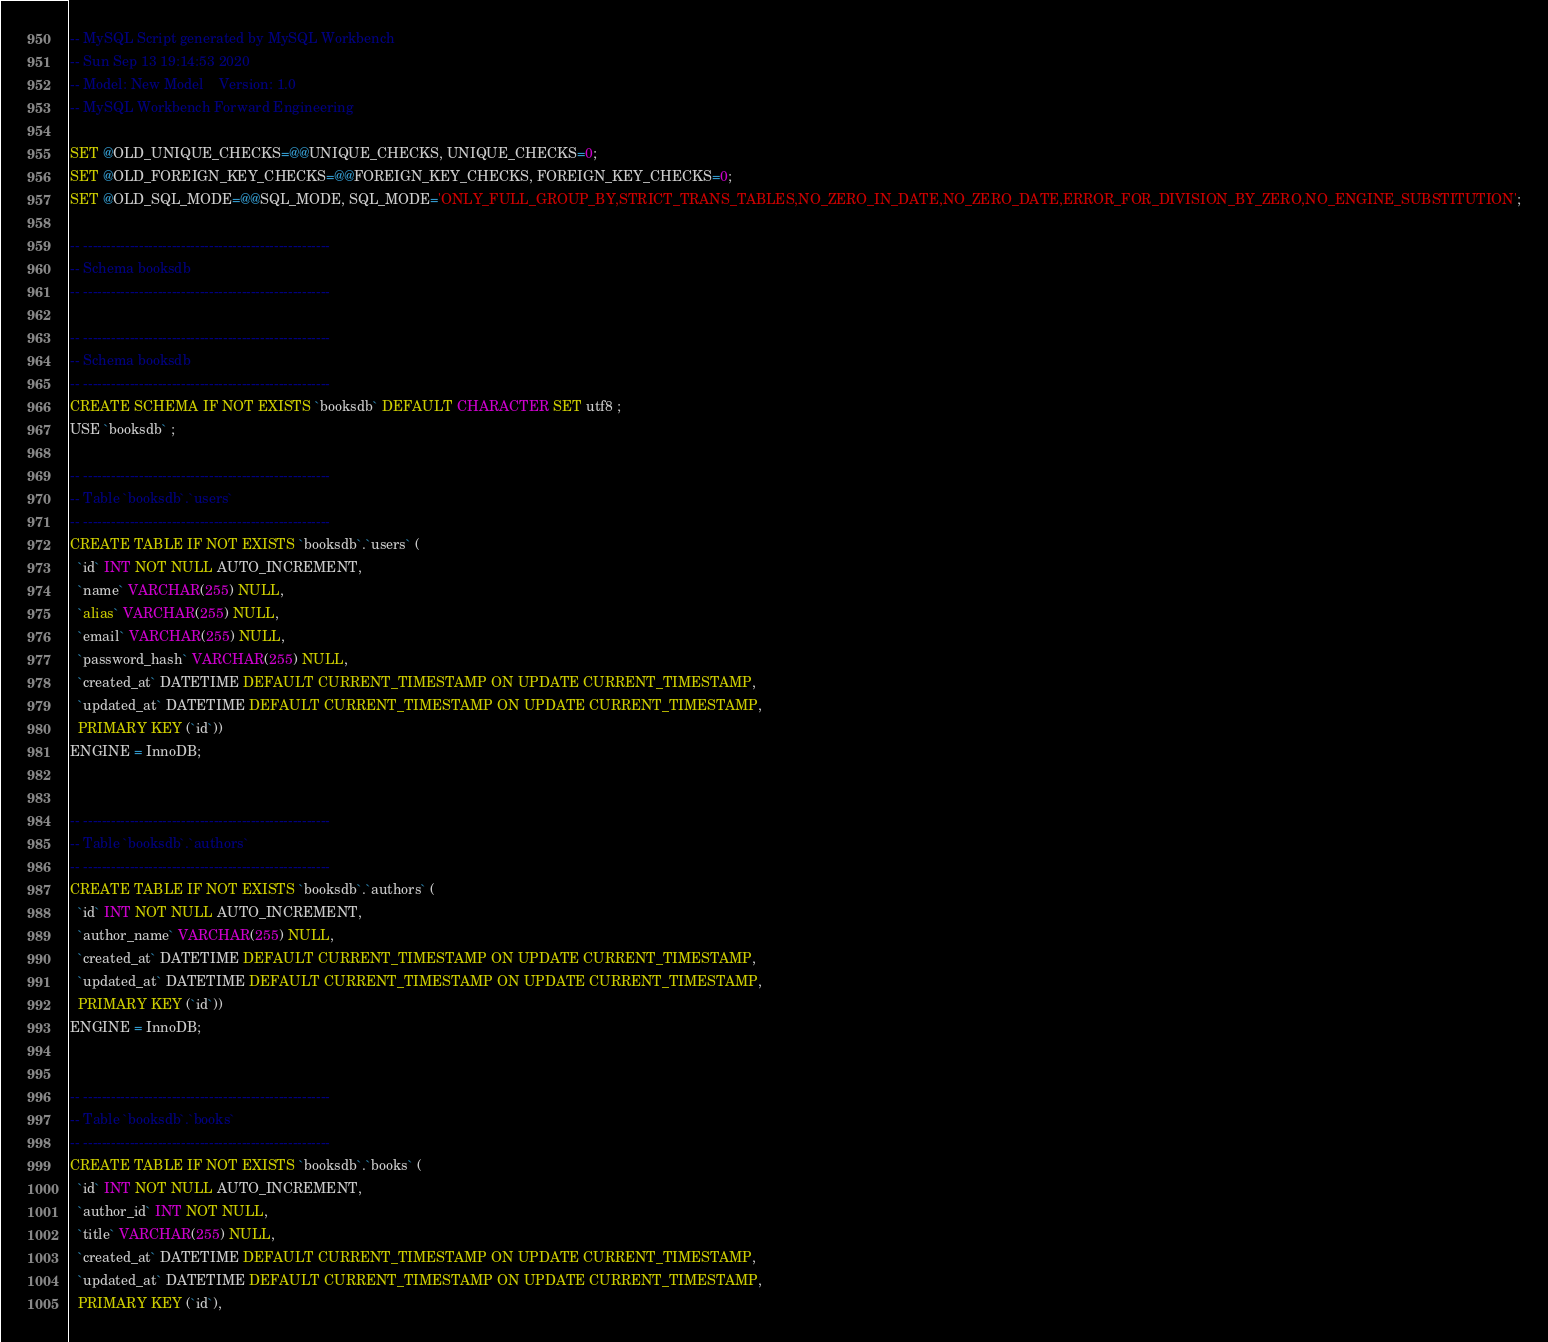<code> <loc_0><loc_0><loc_500><loc_500><_SQL_>-- MySQL Script generated by MySQL Workbench
-- Sun Sep 13 19:14:53 2020
-- Model: New Model    Version: 1.0
-- MySQL Workbench Forward Engineering

SET @OLD_UNIQUE_CHECKS=@@UNIQUE_CHECKS, UNIQUE_CHECKS=0;
SET @OLD_FOREIGN_KEY_CHECKS=@@FOREIGN_KEY_CHECKS, FOREIGN_KEY_CHECKS=0;
SET @OLD_SQL_MODE=@@SQL_MODE, SQL_MODE='ONLY_FULL_GROUP_BY,STRICT_TRANS_TABLES,NO_ZERO_IN_DATE,NO_ZERO_DATE,ERROR_FOR_DIVISION_BY_ZERO,NO_ENGINE_SUBSTITUTION';

-- -----------------------------------------------------
-- Schema booksdb
-- -----------------------------------------------------

-- -----------------------------------------------------
-- Schema booksdb
-- -----------------------------------------------------
CREATE SCHEMA IF NOT EXISTS `booksdb` DEFAULT CHARACTER SET utf8 ;
USE `booksdb` ;

-- -----------------------------------------------------
-- Table `booksdb`.`users`
-- -----------------------------------------------------
CREATE TABLE IF NOT EXISTS `booksdb`.`users` (
  `id` INT NOT NULL AUTO_INCREMENT,
  `name` VARCHAR(255) NULL,
  `alias` VARCHAR(255) NULL,
  `email` VARCHAR(255) NULL,
  `password_hash` VARCHAR(255) NULL,
  `created_at` DATETIME DEFAULT CURRENT_TIMESTAMP ON UPDATE CURRENT_TIMESTAMP,
  `updated_at` DATETIME DEFAULT CURRENT_TIMESTAMP ON UPDATE CURRENT_TIMESTAMP,
  PRIMARY KEY (`id`))
ENGINE = InnoDB;


-- -----------------------------------------------------
-- Table `booksdb`.`authors`
-- -----------------------------------------------------
CREATE TABLE IF NOT EXISTS `booksdb`.`authors` (
  `id` INT NOT NULL AUTO_INCREMENT,
  `author_name` VARCHAR(255) NULL,
  `created_at` DATETIME DEFAULT CURRENT_TIMESTAMP ON UPDATE CURRENT_TIMESTAMP,
  `updated_at` DATETIME DEFAULT CURRENT_TIMESTAMP ON UPDATE CURRENT_TIMESTAMP,
  PRIMARY KEY (`id`))
ENGINE = InnoDB;


-- -----------------------------------------------------
-- Table `booksdb`.`books`
-- -----------------------------------------------------
CREATE TABLE IF NOT EXISTS `booksdb`.`books` (
  `id` INT NOT NULL AUTO_INCREMENT,
  `author_id` INT NOT NULL,
  `title` VARCHAR(255) NULL,
  `created_at` DATETIME DEFAULT CURRENT_TIMESTAMP ON UPDATE CURRENT_TIMESTAMP,
  `updated_at` DATETIME DEFAULT CURRENT_TIMESTAMP ON UPDATE CURRENT_TIMESTAMP,
  PRIMARY KEY (`id`),</code> 